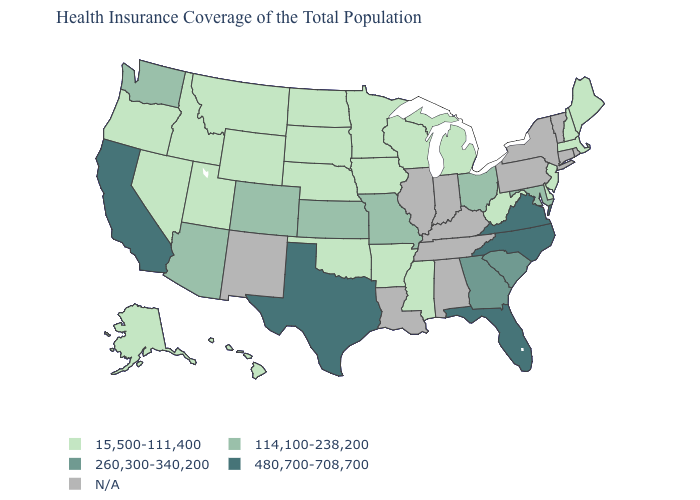Name the states that have a value in the range N/A?
Short answer required. Alabama, Connecticut, Illinois, Indiana, Kentucky, Louisiana, New Mexico, New York, Pennsylvania, Rhode Island, Tennessee, Vermont. What is the highest value in the USA?
Be succinct. 480,700-708,700. Does the first symbol in the legend represent the smallest category?
Short answer required. Yes. Name the states that have a value in the range N/A?
Give a very brief answer. Alabama, Connecticut, Illinois, Indiana, Kentucky, Louisiana, New Mexico, New York, Pennsylvania, Rhode Island, Tennessee, Vermont. What is the lowest value in the USA?
Concise answer only. 15,500-111,400. Name the states that have a value in the range 260,300-340,200?
Give a very brief answer. Georgia, South Carolina. What is the highest value in the West ?
Quick response, please. 480,700-708,700. Which states hav the highest value in the South?
Answer briefly. Florida, North Carolina, Texas, Virginia. What is the highest value in the South ?
Concise answer only. 480,700-708,700. Does Colorado have the highest value in the West?
Be succinct. No. What is the highest value in states that border New Hampshire?
Write a very short answer. 15,500-111,400. 